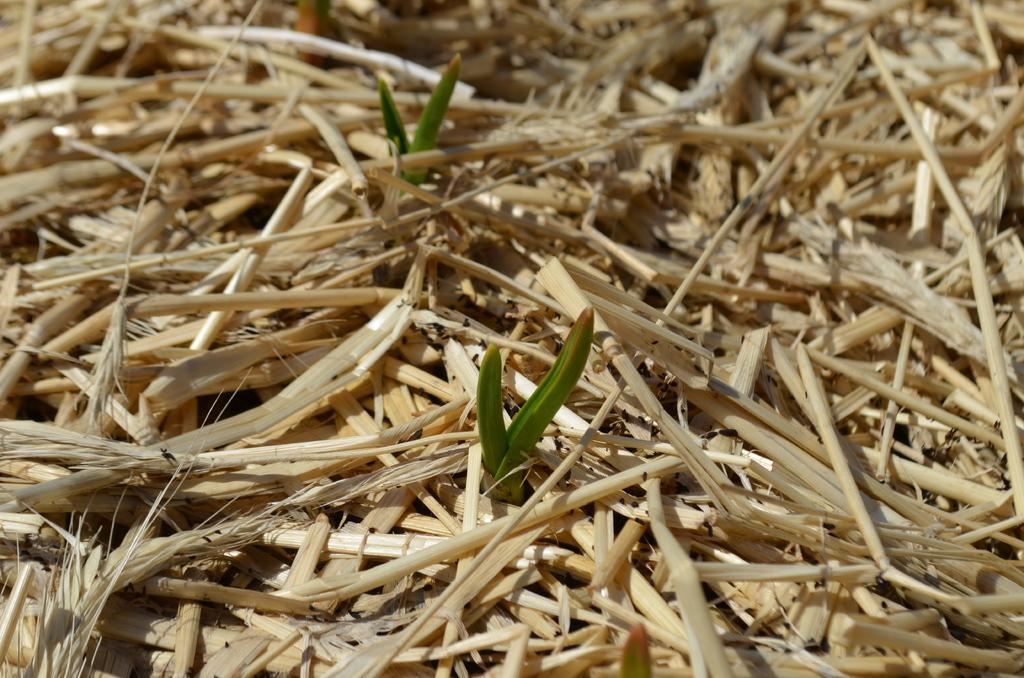What are the two green color objects in the image? There are two green color objects in the image, which appear to be plants. What is the condition of the stems on the ground in the image? Dry stems are lying on the ground in the image. What message of hope is conveyed by the son in the image? There is no son present in the image, and therefore no message of hope can be conveyed. 